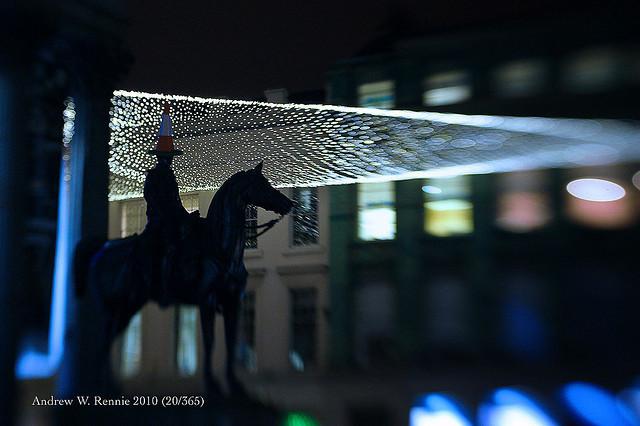Are the lights on in the building?
Answer briefly. Yes. Where is the orange cone?
Keep it brief. On statue. Can the horse be seen the color?
Be succinct. No. 